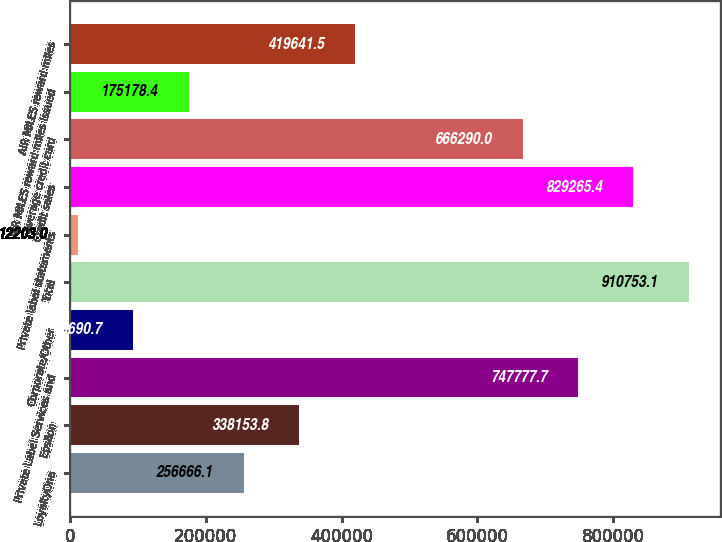Convert chart. <chart><loc_0><loc_0><loc_500><loc_500><bar_chart><fcel>LoyaltyOne<fcel>Epsilon<fcel>Private Label Services and<fcel>Corporate/Other<fcel>Total<fcel>Private label statements<fcel>Credit sales<fcel>Average credit card<fcel>AIR MILES reward miles issued<fcel>AIR MILES reward miles<nl><fcel>256666<fcel>338154<fcel>747778<fcel>93690.7<fcel>910753<fcel>12203<fcel>829265<fcel>666290<fcel>175178<fcel>419642<nl></chart> 